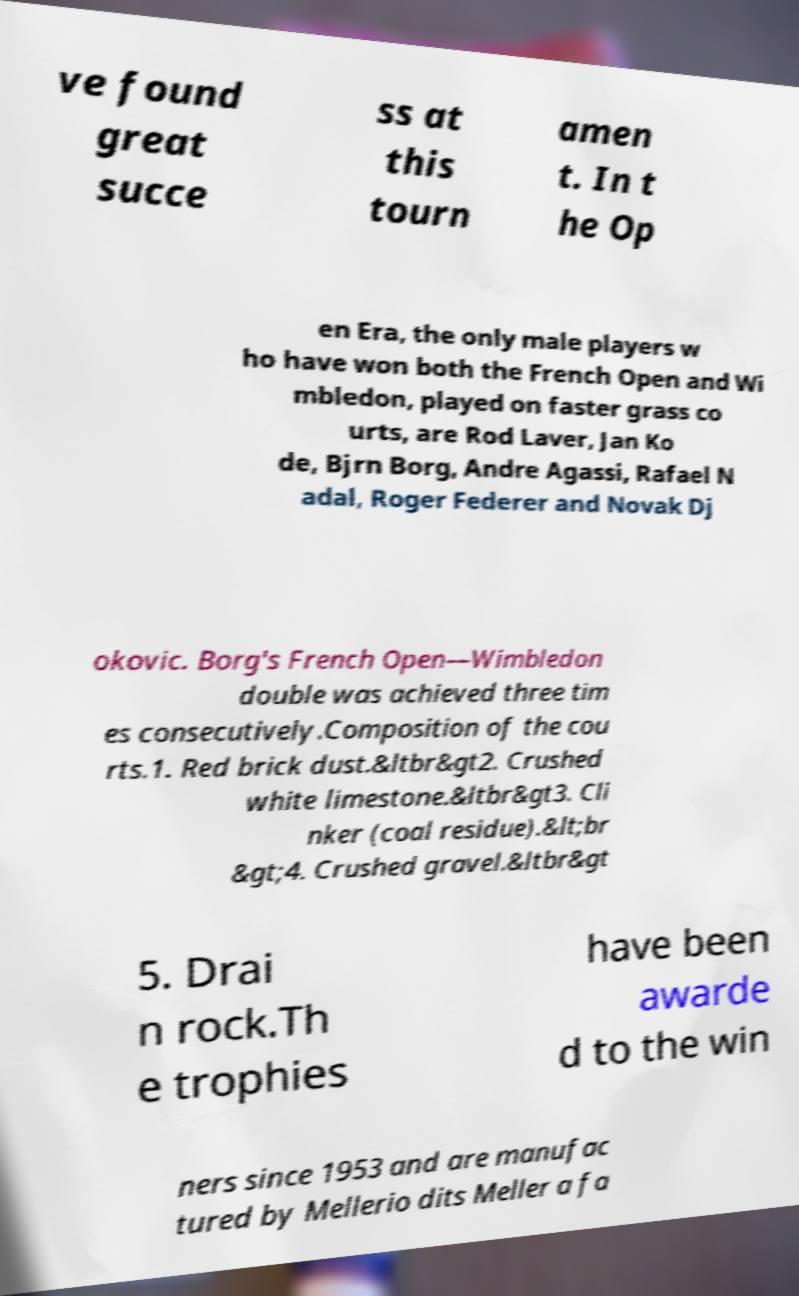There's text embedded in this image that I need extracted. Can you transcribe it verbatim? ve found great succe ss at this tourn amen t. In t he Op en Era, the only male players w ho have won both the French Open and Wi mbledon, played on faster grass co urts, are Rod Laver, Jan Ko de, Bjrn Borg, Andre Agassi, Rafael N adal, Roger Federer and Novak Dj okovic. Borg's French Open—Wimbledon double was achieved three tim es consecutively.Composition of the cou rts.1. Red brick dust.&ltbr&gt2. Crushed white limestone.&ltbr&gt3. Cli nker (coal residue).&lt;br &gt;4. Crushed gravel.&ltbr&gt 5. Drai n rock.Th e trophies have been awarde d to the win ners since 1953 and are manufac tured by Mellerio dits Meller a fa 